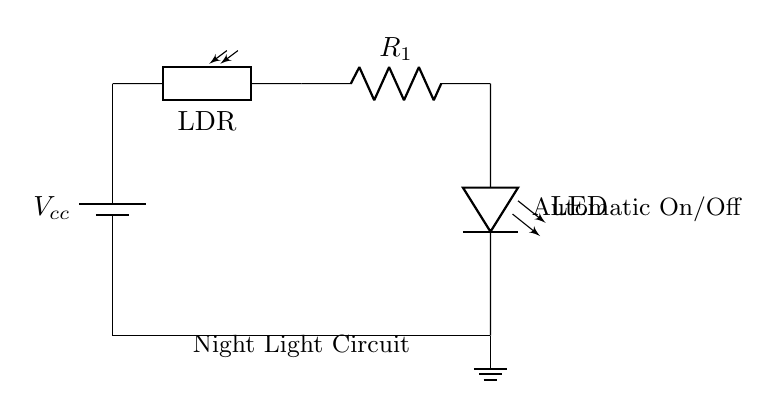What is the function of the photoresistor in the circuit? The photoresistor detects light levels; when it's dark, its resistance increases, allowing current to flow and turning on the LED.
Answer: Detects light What component is used to limit current to the LED? The resistor, labeled as R1, is responsible for limiting the current that flows through the LED to prevent it from burning out.
Answer: Resistor How many main components are there in this circuit? The circuit consists of four main components: the battery, photoresistor, resistor, and LED.
Answer: Four What happens to the LED when light levels are high? When light levels are high, the photoresistor's resistance decreases, resulting in insufficient current to turn on the LED, hence it remains off.
Answer: LED remains off What type of circuit is this? This circuit is a low-power automatic on/off night light circuit that operates based on light conditions found in the environment.
Answer: Automatic on/off night light circuit What is the voltage supply in this circuit? The voltage supply is represented as Vcc in the circuit, which typically denotes the power source for the components.
Answer: Vcc How does the photoresistor affect the LED's operation? The photoresistor modifies its resistance based on ambient light; lower light increases its resistance, allowing LED operation, while higher light decreases resistance, turning the LED off.
Answer: Modulates LED operation 